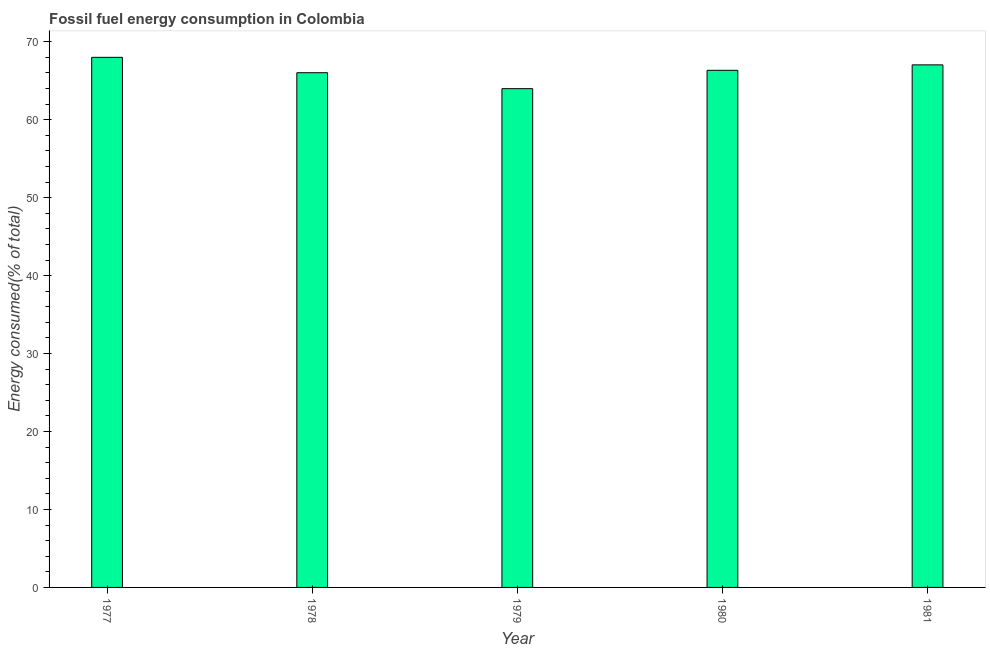Does the graph contain grids?
Your answer should be compact. No. What is the title of the graph?
Make the answer very short. Fossil fuel energy consumption in Colombia. What is the label or title of the X-axis?
Give a very brief answer. Year. What is the label or title of the Y-axis?
Offer a terse response. Energy consumed(% of total). What is the fossil fuel energy consumption in 1977?
Provide a short and direct response. 68. Across all years, what is the maximum fossil fuel energy consumption?
Ensure brevity in your answer.  68. Across all years, what is the minimum fossil fuel energy consumption?
Provide a short and direct response. 63.98. In which year was the fossil fuel energy consumption maximum?
Provide a succinct answer. 1977. In which year was the fossil fuel energy consumption minimum?
Provide a short and direct response. 1979. What is the sum of the fossil fuel energy consumption?
Ensure brevity in your answer.  331.37. What is the difference between the fossil fuel energy consumption in 1977 and 1980?
Your answer should be compact. 1.67. What is the average fossil fuel energy consumption per year?
Your answer should be very brief. 66.27. What is the median fossil fuel energy consumption?
Your answer should be very brief. 66.33. In how many years, is the fossil fuel energy consumption greater than 18 %?
Offer a very short reply. 5. Do a majority of the years between 1980 and 1981 (inclusive) have fossil fuel energy consumption greater than 64 %?
Your answer should be very brief. Yes. What is the ratio of the fossil fuel energy consumption in 1979 to that in 1981?
Provide a succinct answer. 0.95. Is the difference between the fossil fuel energy consumption in 1977 and 1978 greater than the difference between any two years?
Offer a very short reply. No. What is the difference between the highest and the second highest fossil fuel energy consumption?
Provide a short and direct response. 0.97. Is the sum of the fossil fuel energy consumption in 1977 and 1980 greater than the maximum fossil fuel energy consumption across all years?
Offer a terse response. Yes. What is the difference between the highest and the lowest fossil fuel energy consumption?
Provide a short and direct response. 4.02. Are all the bars in the graph horizontal?
Your answer should be very brief. No. What is the difference between two consecutive major ticks on the Y-axis?
Ensure brevity in your answer.  10. What is the Energy consumed(% of total) of 1977?
Your answer should be compact. 68. What is the Energy consumed(% of total) of 1978?
Your answer should be compact. 66.03. What is the Energy consumed(% of total) of 1979?
Offer a terse response. 63.98. What is the Energy consumed(% of total) in 1980?
Offer a terse response. 66.33. What is the Energy consumed(% of total) in 1981?
Your response must be concise. 67.03. What is the difference between the Energy consumed(% of total) in 1977 and 1978?
Keep it short and to the point. 1.97. What is the difference between the Energy consumed(% of total) in 1977 and 1979?
Offer a terse response. 4.02. What is the difference between the Energy consumed(% of total) in 1977 and 1980?
Your answer should be very brief. 1.67. What is the difference between the Energy consumed(% of total) in 1977 and 1981?
Your answer should be very brief. 0.97. What is the difference between the Energy consumed(% of total) in 1978 and 1979?
Your response must be concise. 2.05. What is the difference between the Energy consumed(% of total) in 1978 and 1980?
Your answer should be very brief. -0.31. What is the difference between the Energy consumed(% of total) in 1978 and 1981?
Ensure brevity in your answer.  -1.01. What is the difference between the Energy consumed(% of total) in 1979 and 1980?
Provide a succinct answer. -2.35. What is the difference between the Energy consumed(% of total) in 1979 and 1981?
Ensure brevity in your answer.  -3.05. What is the difference between the Energy consumed(% of total) in 1980 and 1981?
Your response must be concise. -0.7. What is the ratio of the Energy consumed(% of total) in 1977 to that in 1979?
Provide a succinct answer. 1.06. What is the ratio of the Energy consumed(% of total) in 1978 to that in 1979?
Ensure brevity in your answer.  1.03. What is the ratio of the Energy consumed(% of total) in 1979 to that in 1980?
Offer a very short reply. 0.96. What is the ratio of the Energy consumed(% of total) in 1979 to that in 1981?
Offer a terse response. 0.95. 